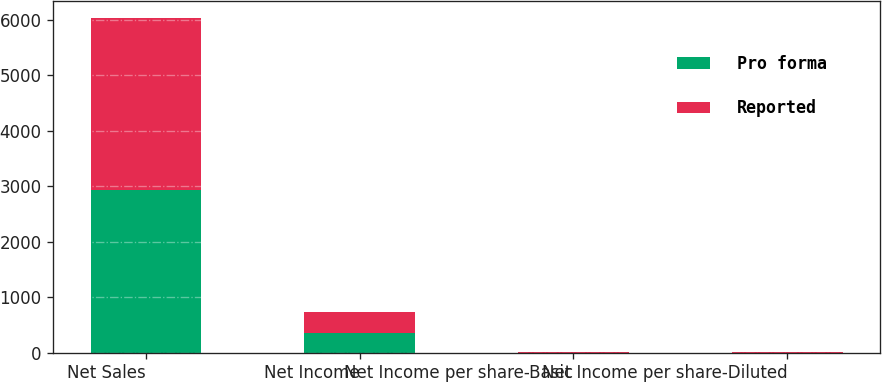Convert chart to OTSL. <chart><loc_0><loc_0><loc_500><loc_500><stacked_bar_chart><ecel><fcel>Net Sales<fcel>Net Income<fcel>Net Income per share-Basic<fcel>Net Income per share-Diluted<nl><fcel>Pro forma<fcel>2921.9<fcel>349.8<fcel>2.5<fcel>2.45<nl><fcel>Reported<fcel>3106<fcel>374.9<fcel>2.68<fcel>2.63<nl></chart> 